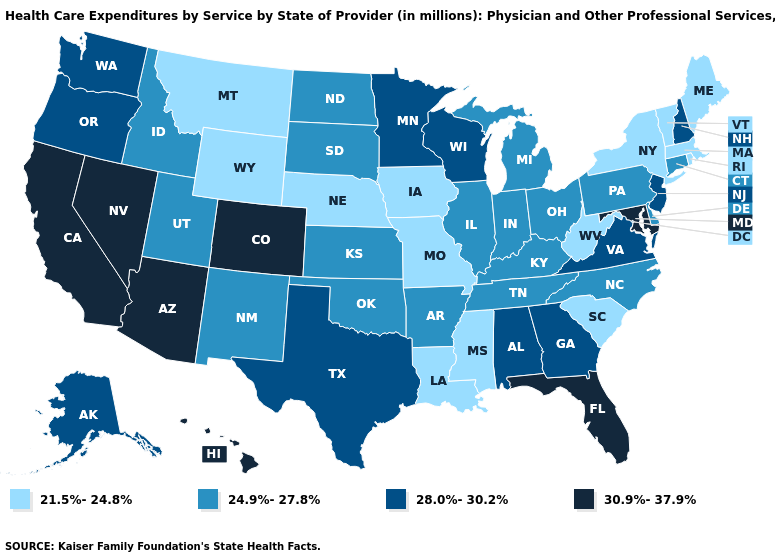Does Indiana have the highest value in the USA?
Quick response, please. No. Does Florida have the highest value in the USA?
Write a very short answer. Yes. Name the states that have a value in the range 28.0%-30.2%?
Give a very brief answer. Alabama, Alaska, Georgia, Minnesota, New Hampshire, New Jersey, Oregon, Texas, Virginia, Washington, Wisconsin. Name the states that have a value in the range 24.9%-27.8%?
Concise answer only. Arkansas, Connecticut, Delaware, Idaho, Illinois, Indiana, Kansas, Kentucky, Michigan, New Mexico, North Carolina, North Dakota, Ohio, Oklahoma, Pennsylvania, South Dakota, Tennessee, Utah. Name the states that have a value in the range 30.9%-37.9%?
Concise answer only. Arizona, California, Colorado, Florida, Hawaii, Maryland, Nevada. Name the states that have a value in the range 24.9%-27.8%?
Give a very brief answer. Arkansas, Connecticut, Delaware, Idaho, Illinois, Indiana, Kansas, Kentucky, Michigan, New Mexico, North Carolina, North Dakota, Ohio, Oklahoma, Pennsylvania, South Dakota, Tennessee, Utah. Name the states that have a value in the range 24.9%-27.8%?
Answer briefly. Arkansas, Connecticut, Delaware, Idaho, Illinois, Indiana, Kansas, Kentucky, Michigan, New Mexico, North Carolina, North Dakota, Ohio, Oklahoma, Pennsylvania, South Dakota, Tennessee, Utah. Name the states that have a value in the range 30.9%-37.9%?
Concise answer only. Arizona, California, Colorado, Florida, Hawaii, Maryland, Nevada. Does Alabama have the same value as Georgia?
Short answer required. Yes. What is the value of South Carolina?
Quick response, please. 21.5%-24.8%. What is the highest value in states that border Delaware?
Quick response, please. 30.9%-37.9%. What is the value of Missouri?
Concise answer only. 21.5%-24.8%. Which states have the lowest value in the USA?
Short answer required. Iowa, Louisiana, Maine, Massachusetts, Mississippi, Missouri, Montana, Nebraska, New York, Rhode Island, South Carolina, Vermont, West Virginia, Wyoming. What is the value of Florida?
Answer briefly. 30.9%-37.9%. 